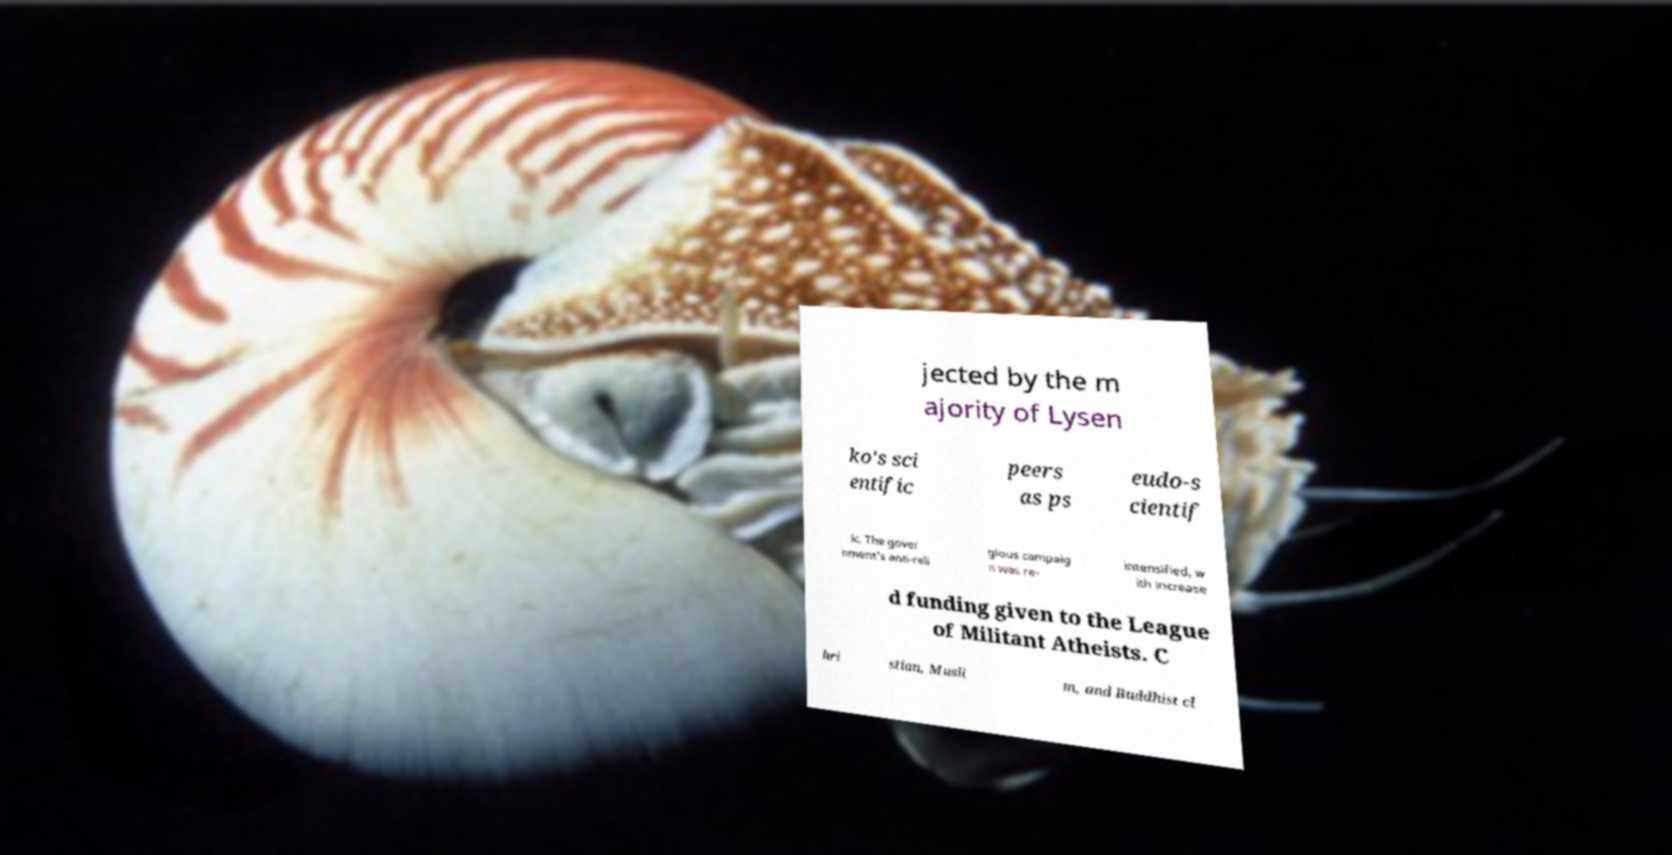Please read and relay the text visible in this image. What does it say? jected by the m ajority of Lysen ko's sci entific peers as ps eudo-s cientif ic. The gover nment's anti-reli gious campaig n was re- intensified, w ith increase d funding given to the League of Militant Atheists. C hri stian, Musli m, and Buddhist cl 